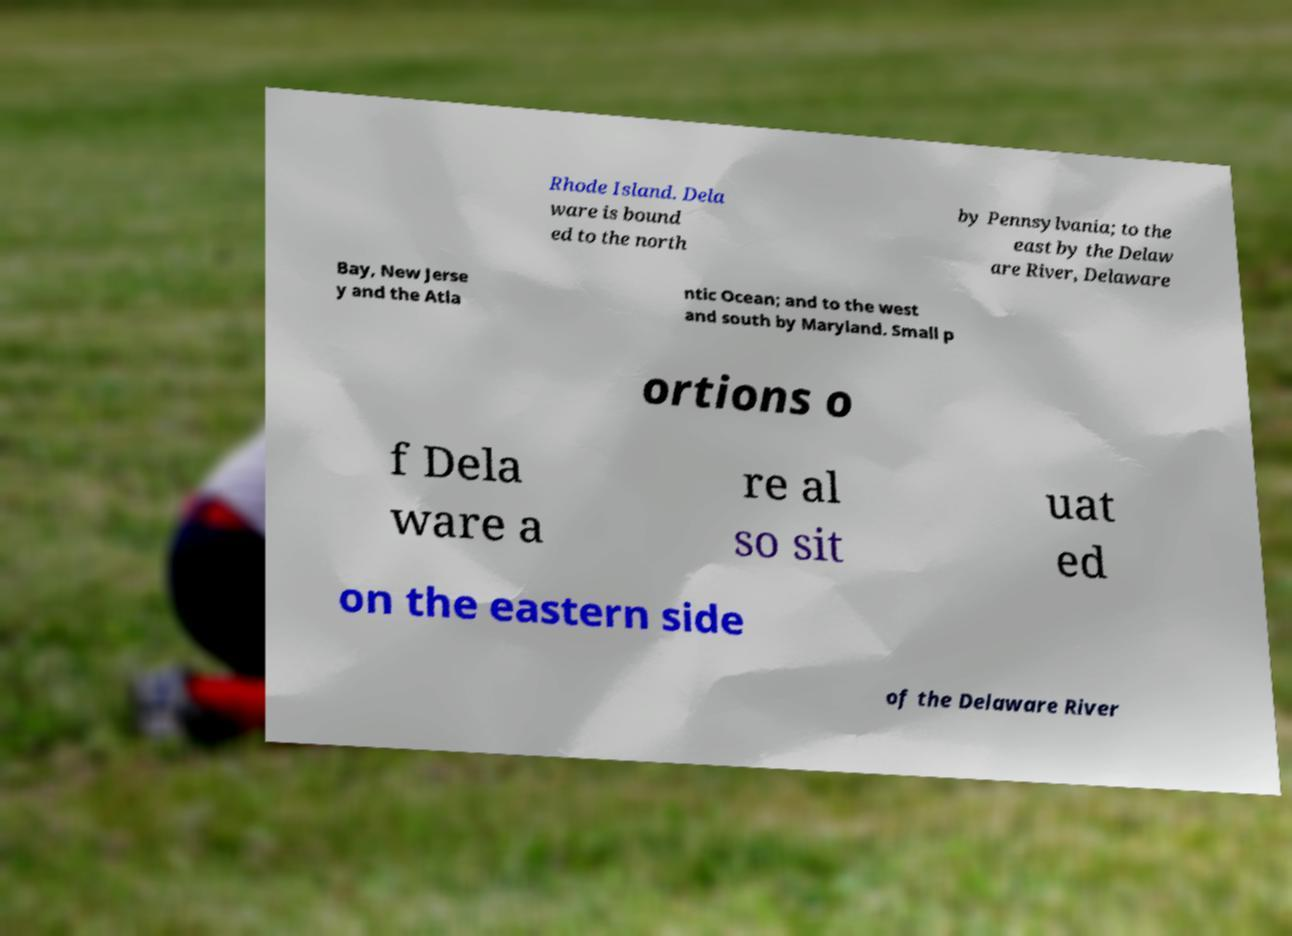Can you read and provide the text displayed in the image?This photo seems to have some interesting text. Can you extract and type it out for me? Rhode Island. Dela ware is bound ed to the north by Pennsylvania; to the east by the Delaw are River, Delaware Bay, New Jerse y and the Atla ntic Ocean; and to the west and south by Maryland. Small p ortions o f Dela ware a re al so sit uat ed on the eastern side of the Delaware River 